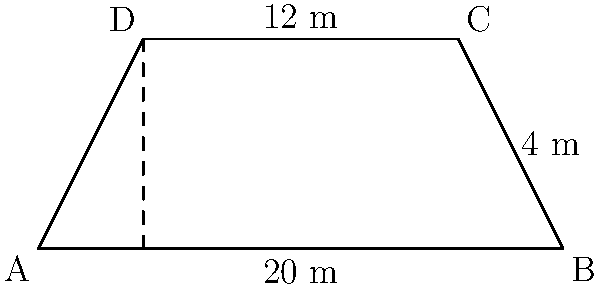Farmer John's pasture has a unique trapezoid shape. The parallel sides measure 20 meters and 12 meters, and the height of the trapezoid is 4 meters. What is the area of this pasture in square meters? To find the area of a trapezoid, we can use the formula:

$$A = \frac{1}{2}(b_1 + b_2)h$$

Where:
$A$ = Area
$b_1$ = Length of one parallel side
$b_2$ = Length of the other parallel side
$h$ = Height (perpendicular distance between the parallel sides)

Given:
$b_1 = 20$ meters
$b_2 = 12$ meters
$h = 4$ meters

Let's substitute these values into the formula:

$$A = \frac{1}{2}(20 + 12) \times 4$$

$$A = \frac{1}{2}(32) \times 4$$

$$A = 16 \times 4$$

$$A = 64$$

Therefore, the area of Farmer John's trapezoid-shaped pasture is 64 square meters.
Answer: 64 m² 